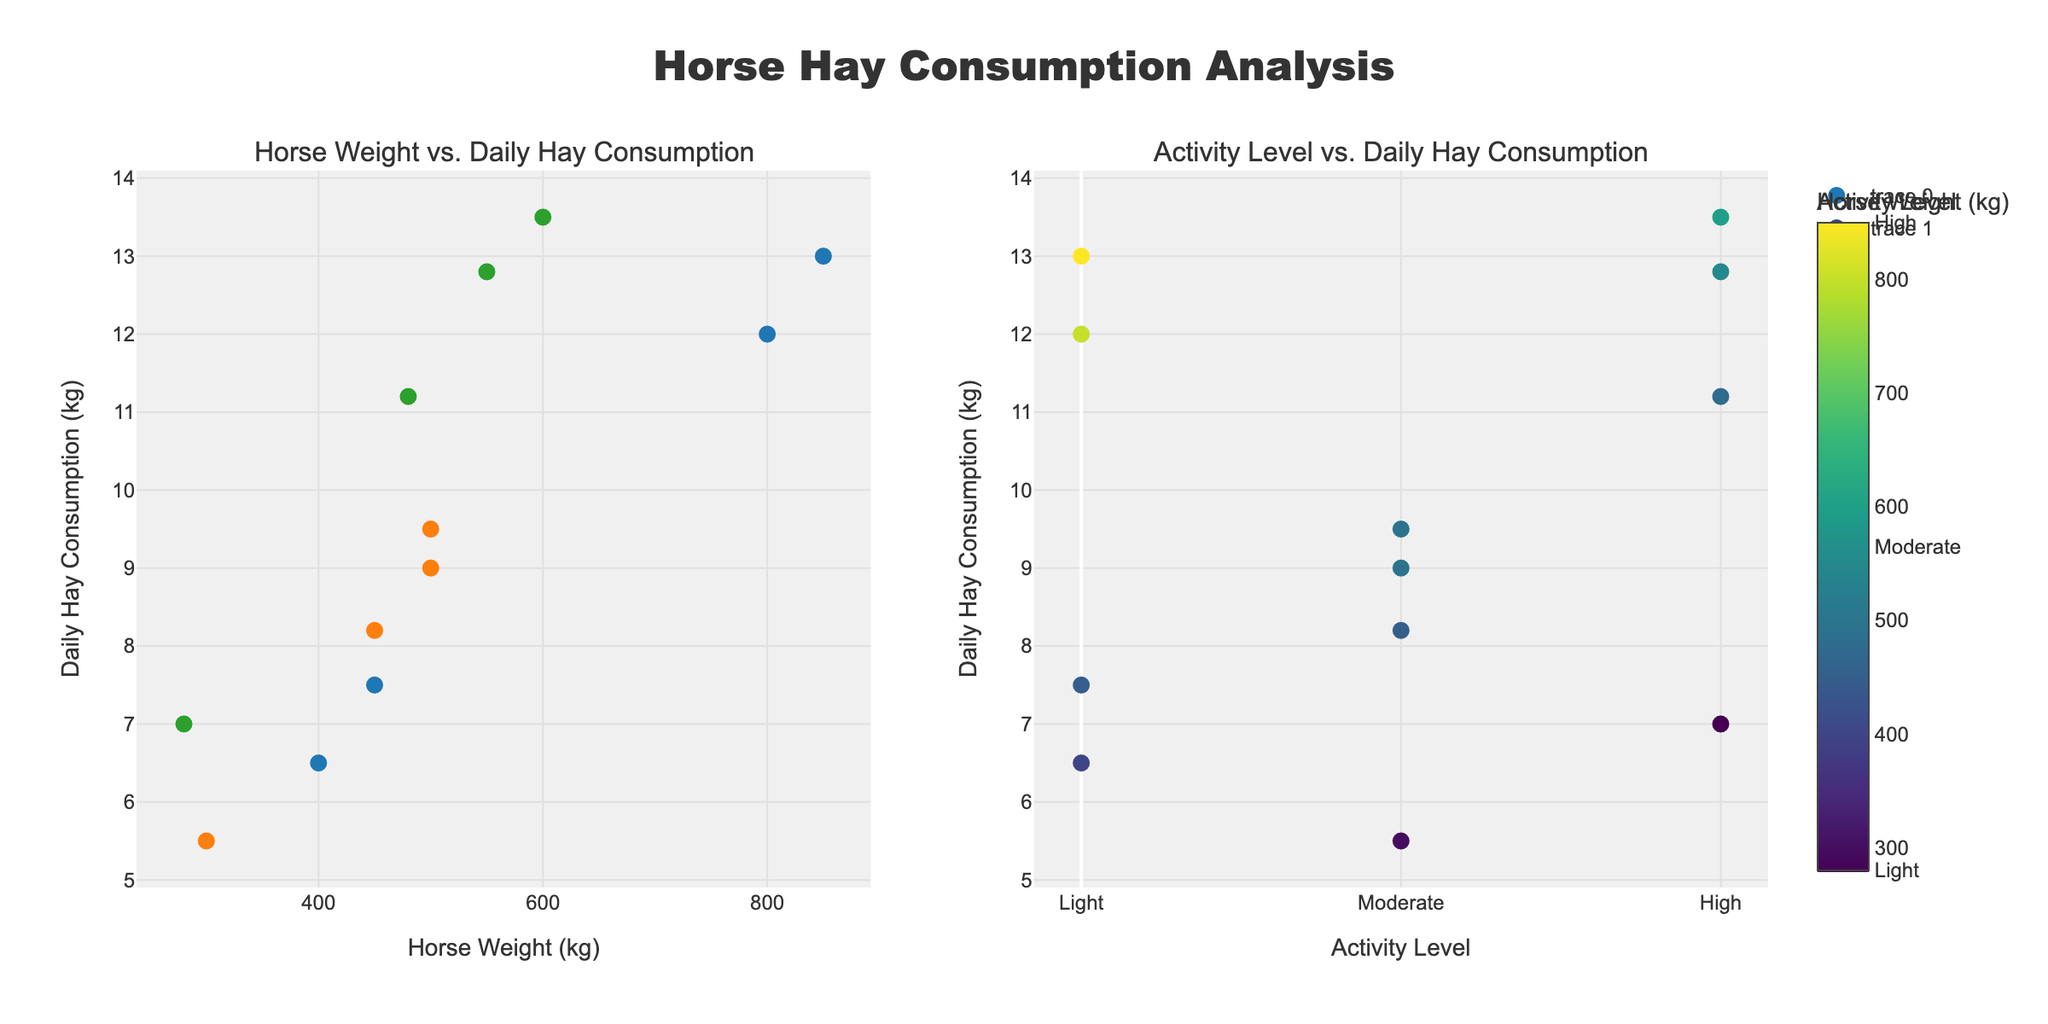Which horse consumes the most daily hay? From the plots, the horse with the highest y-value on the hay consumption axis is the Warmblood, consuming approximately 13.5 kg of hay daily.
Answer: Warmblood How does a Clydesdale's daily hay consumption compare to a Draft Horse's? On the first plot, both horses are plotted with light activity and weights around 800-850 kg. The y-values for hay consumption show the Clydesdale consumes 13 kg, while the Draft Horse consumes 12 kg.
Answer: Clydesdale consumes more What color represents horses with moderate activity level in the weight vs hay consumption plot? The color scale in the first plot shows moderate activity horses in orange.
Answer: Orange What is the average daily hay consumption for horses with high activity levels? From the plot, the high-activity horses are Thoroughbred (11.2), Warmblood (13.5), Friesian (12.8), and Welsh Pony (7.0). Average: (11.2 + 13.5 + 12.8 + 7.0) / 4 = 11.125 kg.
Answer: 11.125 kg Which horse has the lowest hay consumption among those with moderate activity? In the second plot, among the horses with moderate activity (pony, Morgan, Andalusian, Quarter Horse) the Pony has the lowest y-value, indicating 5.5 kg of hay.
Answer: Pony Are all the largest horses in terms of weight highly active? From the first plot, not all heavy horses (Draft Horse, Clydesdale) are highly active. They fall under the light activity level.
Answer: No Which horse has the highest weight and light activity level? From the left plot, the highest weight horse under the light activity color code is the Clydesdale, weighing 850 kg.
Answer: Clydesdale What's the correlation between horse weight and daily hay consumption overall? Observing the first subplot, a general upward trend is visible: higher weight correlates with higher hay consumption.
Answer: Positive correlation 